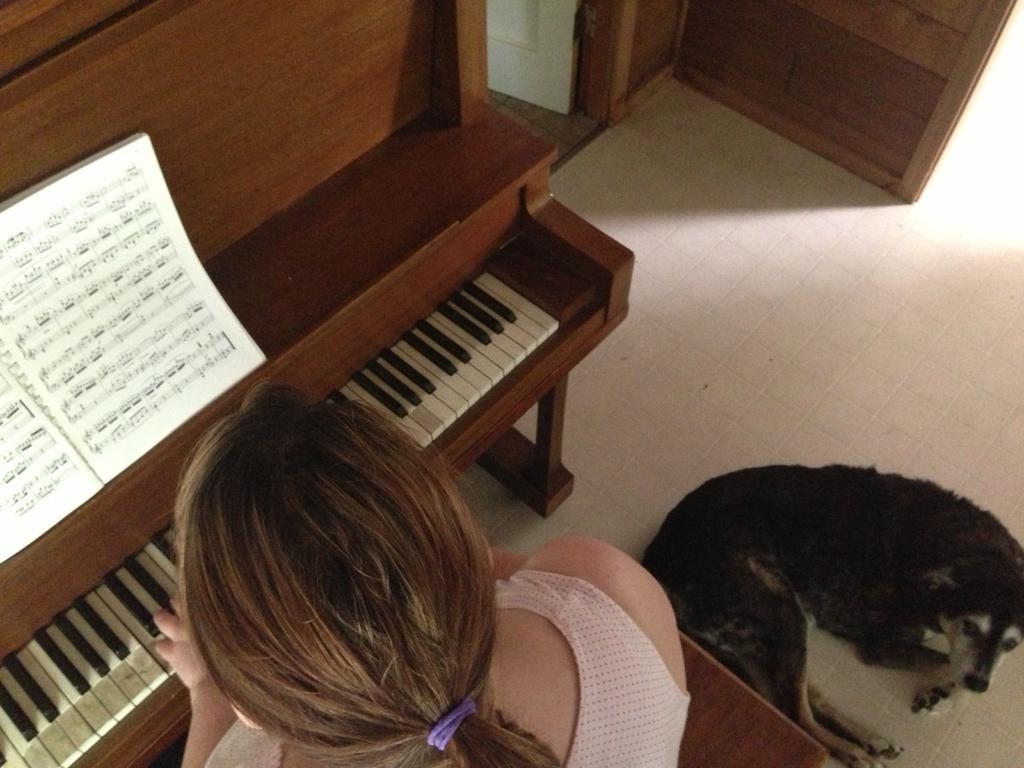Please provide a concise description of this image. In this image there is a woman sitting in the chair and playing the piano with the book and at the back ground there is a dog in the floor. 